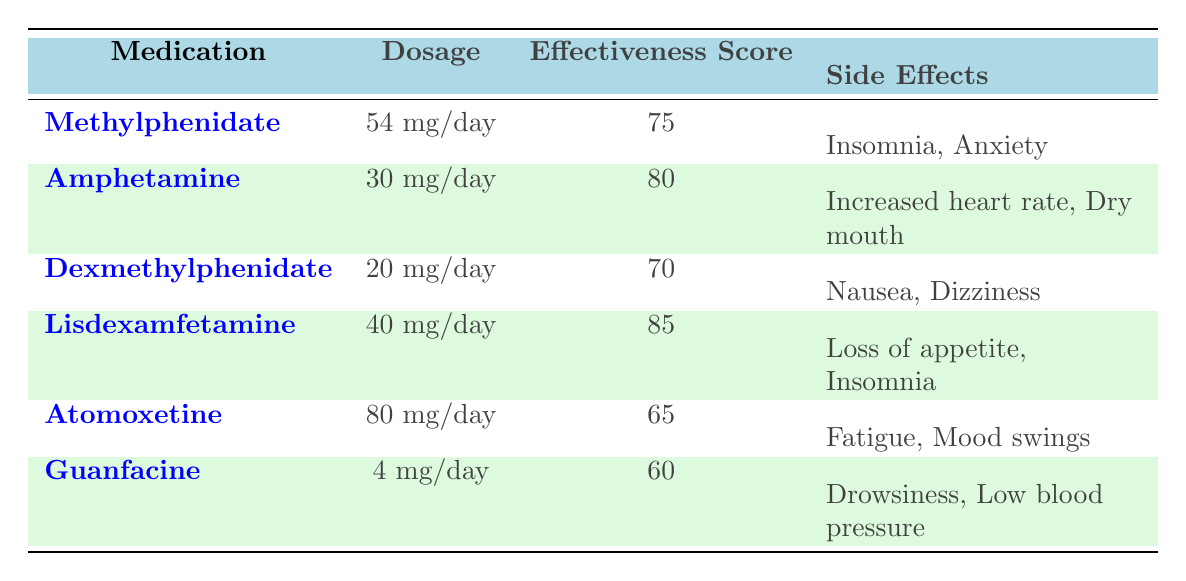What is the effectiveness score of Lisdexamfetamine? The table lists Lisdexamfetamine under the medications section with an effectiveness score of 85.
Answer: 85 Which medication has the highest effectiveness score? Among the medications listed, Lisdexamfetamine has the highest effectiveness score of 85.
Answer: Lisdexamfetamine What are the side effects of Amphetamine? The table indicates that the side effects of Amphetamine are increased heart rate and dry mouth.
Answer: Increased heart rate, dry mouth Is the effectiveness score of Atomoxetine greater than 70? The effectiveness score for Atomoxetine is 65, which is less than 70, making the statement false.
Answer: No What is the average effectiveness score of all listed medications? The effectiveness scores are 75, 80, 70, 85, 65, and 60. Summing these scores gives 435. Dividing by 6 (the total number of medications) results in an average of 72.5.
Answer: 72.5 How many medications have side effects that include insomnia? From the table, Methylphenidate and Lisdexamfetamine both report insomnia as a side effect. This totals to 2 medications.
Answer: 2 Which medication has the lowest effectiveness score, and what is that score? The table shows that Guanfacine has the lowest effectiveness score of 60.
Answer: Guanfacine, 60 Is Dexmethylphenidate more effective than Atomoxetine? Comparing the effectiveness scores, Dexmethylphenidate has 70, which is greater than Atomoxetine's score of 65, indicating that Dexmethylphenidate is more effective.
Answer: Yes 